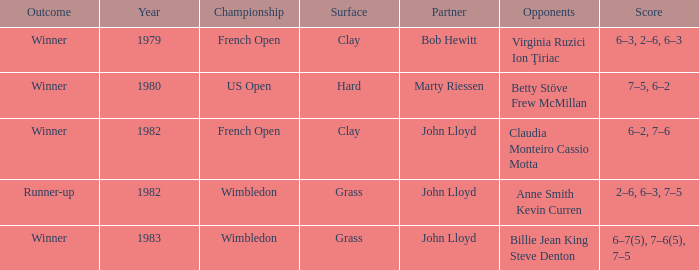Who were the opponents that led to an outcome of winner on a grass surface? Billie Jean King Steve Denton. 